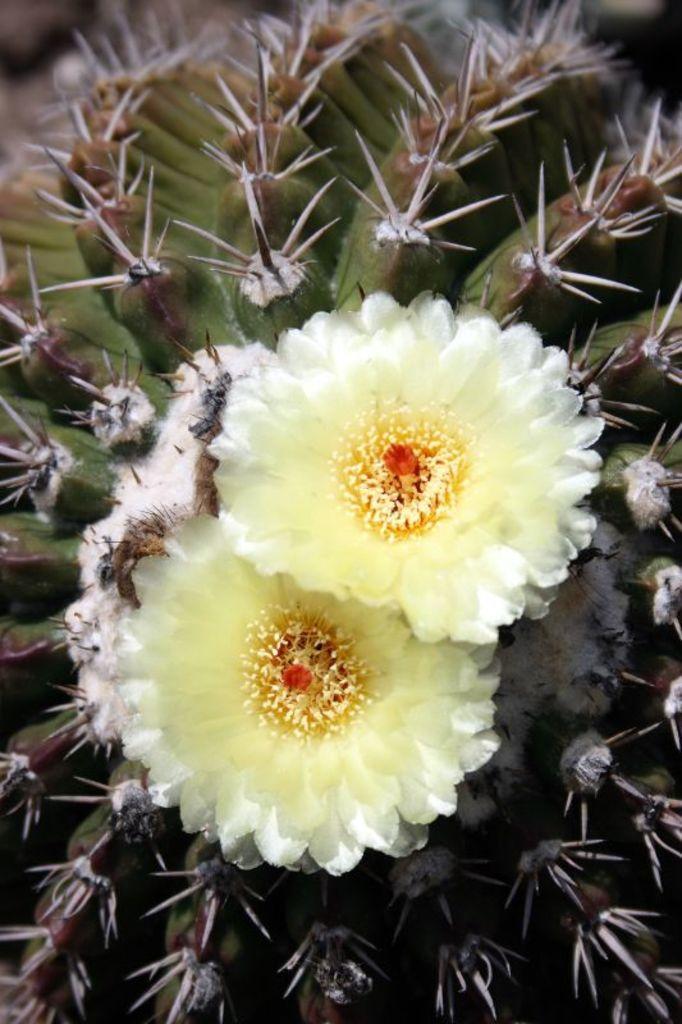In one or two sentences, can you explain what this image depicts? In this image we can see white color flowers, background some stems are present. 